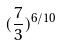Convert formula to latex. <formula><loc_0><loc_0><loc_500><loc_500>( \frac { 7 } { 3 } ) ^ { 6 / 1 0 }</formula> 